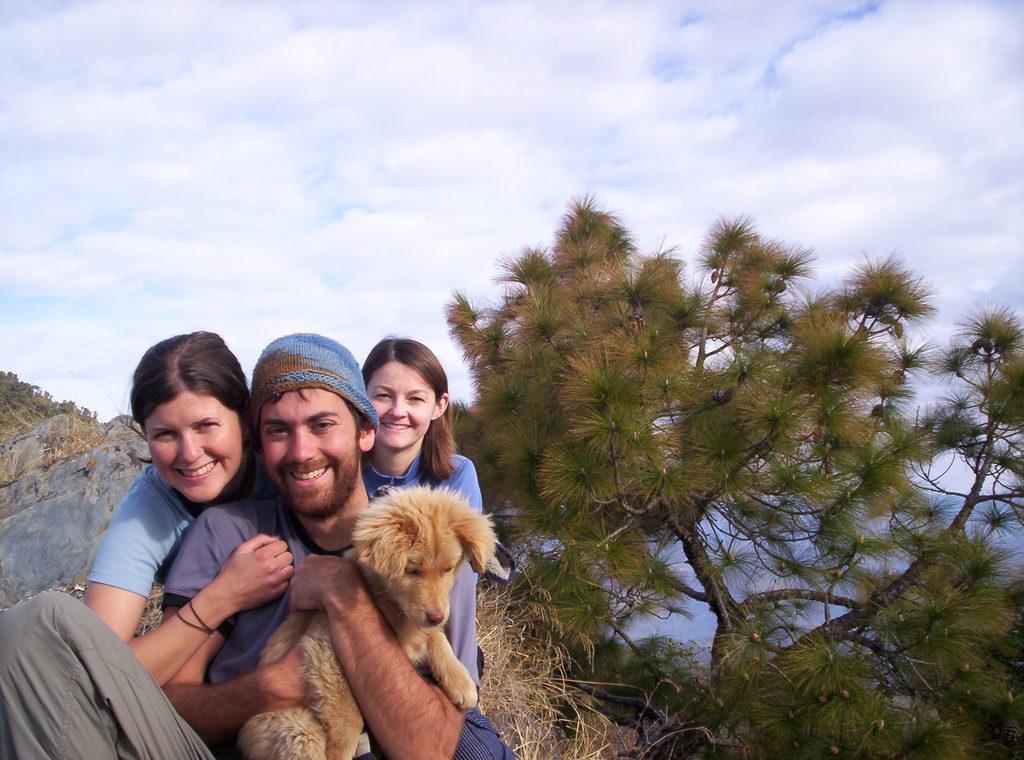Describe this image in one or two sentences. In this Image I see a man who is holding the dog and behind to him there are 2 women and all of them are smiling. In the background I see the trees and the sky. 